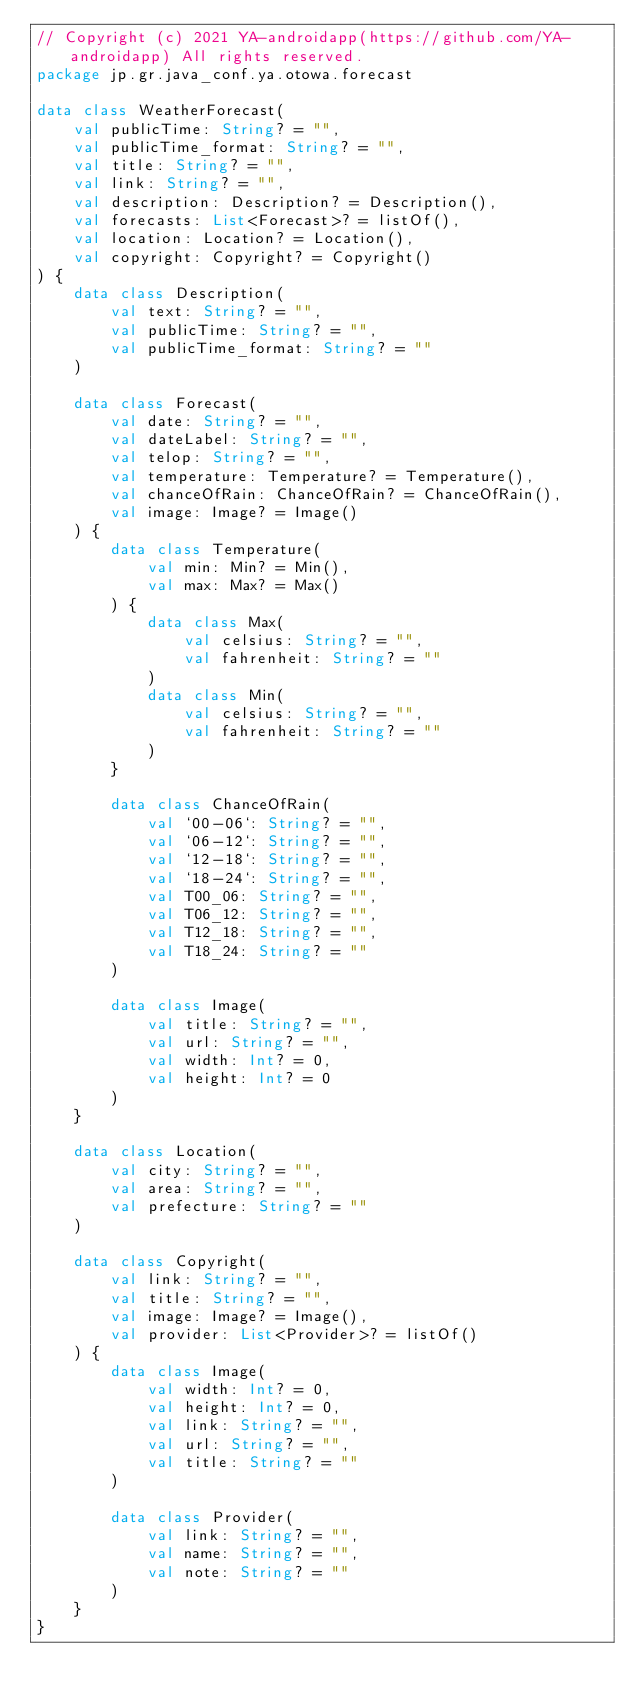Convert code to text. <code><loc_0><loc_0><loc_500><loc_500><_Kotlin_>// Copyright (c) 2021 YA-androidapp(https://github.com/YA-androidapp) All rights reserved.
package jp.gr.java_conf.ya.otowa.forecast

data class WeatherForecast(
    val publicTime: String? = "",
    val publicTime_format: String? = "",
    val title: String? = "",
    val link: String? = "",
    val description: Description? = Description(),
    val forecasts: List<Forecast>? = listOf(),
    val location: Location? = Location(),
    val copyright: Copyright? = Copyright()
) {
    data class Description(
        val text: String? = "",
        val publicTime: String? = "",
        val publicTime_format: String? = ""
    )

    data class Forecast(
        val date: String? = "",
        val dateLabel: String? = "",
        val telop: String? = "",
        val temperature: Temperature? = Temperature(),
        val chanceOfRain: ChanceOfRain? = ChanceOfRain(),
        val image: Image? = Image()
    ) {
        data class Temperature(
            val min: Min? = Min(),
            val max: Max? = Max()
        ) {
            data class Max(
                val celsius: String? = "",
                val fahrenheit: String? = ""
            )
            data class Min(
                val celsius: String? = "",
                val fahrenheit: String? = ""
            )
        }

        data class ChanceOfRain(
            val `00-06`: String? = "",
            val `06-12`: String? = "",
            val `12-18`: String? = "",
            val `18-24`: String? = "",
            val T00_06: String? = "",
            val T06_12: String? = "",
            val T12_18: String? = "",
            val T18_24: String? = ""
        )

        data class Image(
            val title: String? = "",
            val url: String? = "",
            val width: Int? = 0,
            val height: Int? = 0
        )
    }

    data class Location(
        val city: String? = "",
        val area: String? = "",
        val prefecture: String? = ""
    )

    data class Copyright(
        val link: String? = "",
        val title: String? = "",
        val image: Image? = Image(),
        val provider: List<Provider>? = listOf()
    ) {
        data class Image(
            val width: Int? = 0,
            val height: Int? = 0,
            val link: String? = "",
            val url: String? = "",
            val title: String? = ""
        )

        data class Provider(
            val link: String? = "",
            val name: String? = "",
            val note: String? = ""
        )
    }
}</code> 